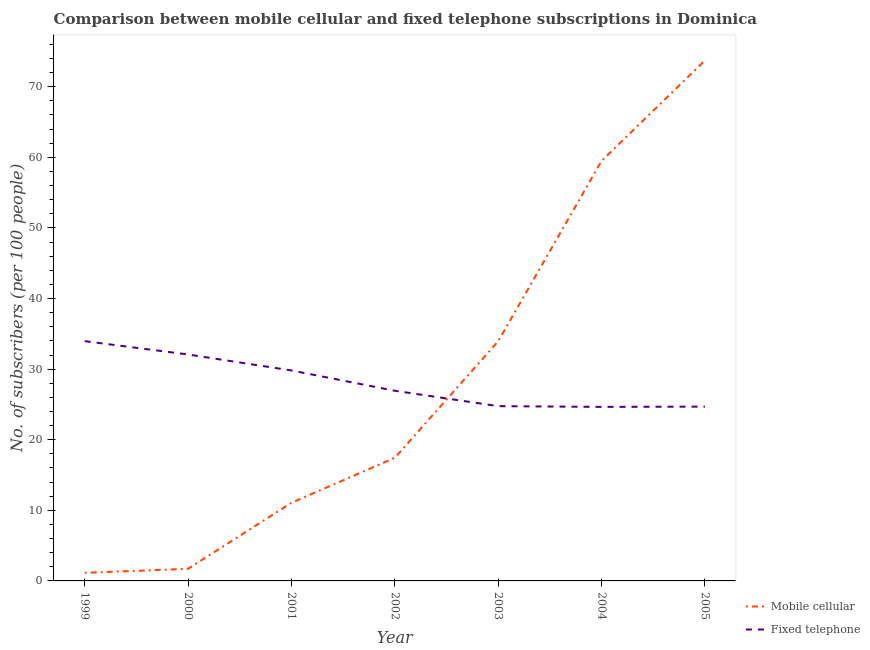Does the line corresponding to number of mobile cellular subscribers intersect with the line corresponding to number of fixed telephone subscribers?
Provide a short and direct response. Yes. Is the number of lines equal to the number of legend labels?
Your response must be concise. Yes. What is the number of mobile cellular subscribers in 2004?
Your answer should be compact. 59.49. Across all years, what is the maximum number of mobile cellular subscribers?
Offer a very short reply. 73.71. Across all years, what is the minimum number of fixed telephone subscribers?
Offer a very short reply. 24.65. In which year was the number of mobile cellular subscribers minimum?
Provide a short and direct response. 1999. What is the total number of mobile cellular subscribers in the graph?
Offer a terse response. 198.53. What is the difference between the number of fixed telephone subscribers in 2002 and that in 2005?
Your answer should be very brief. 2.25. What is the difference between the number of mobile cellular subscribers in 2003 and the number of fixed telephone subscribers in 1999?
Your response must be concise. -0.01. What is the average number of mobile cellular subscribers per year?
Offer a terse response. 28.36. In the year 2002, what is the difference between the number of mobile cellular subscribers and number of fixed telephone subscribers?
Keep it short and to the point. -9.5. What is the ratio of the number of mobile cellular subscribers in 2003 to that in 2004?
Provide a short and direct response. 0.57. Is the number of mobile cellular subscribers in 2001 less than that in 2003?
Offer a terse response. Yes. Is the difference between the number of mobile cellular subscribers in 2000 and 2004 greater than the difference between the number of fixed telephone subscribers in 2000 and 2004?
Offer a very short reply. No. What is the difference between the highest and the second highest number of fixed telephone subscribers?
Give a very brief answer. 1.89. What is the difference between the highest and the lowest number of fixed telephone subscribers?
Your answer should be compact. 9.31. In how many years, is the number of fixed telephone subscribers greater than the average number of fixed telephone subscribers taken over all years?
Your answer should be very brief. 3. Is the number of fixed telephone subscribers strictly less than the number of mobile cellular subscribers over the years?
Ensure brevity in your answer.  No. How many years are there in the graph?
Offer a terse response. 7. What is the difference between two consecutive major ticks on the Y-axis?
Provide a succinct answer. 10. Where does the legend appear in the graph?
Your answer should be compact. Bottom right. How many legend labels are there?
Your answer should be compact. 2. How are the legend labels stacked?
Your response must be concise. Vertical. What is the title of the graph?
Give a very brief answer. Comparison between mobile cellular and fixed telephone subscriptions in Dominica. What is the label or title of the X-axis?
Ensure brevity in your answer.  Year. What is the label or title of the Y-axis?
Keep it short and to the point. No. of subscribers (per 100 people). What is the No. of subscribers (per 100 people) of Mobile cellular in 1999?
Provide a short and direct response. 1.14. What is the No. of subscribers (per 100 people) of Fixed telephone in 1999?
Keep it short and to the point. 33.96. What is the No. of subscribers (per 100 people) in Mobile cellular in 2000?
Give a very brief answer. 1.72. What is the No. of subscribers (per 100 people) in Fixed telephone in 2000?
Your response must be concise. 32.07. What is the No. of subscribers (per 100 people) of Mobile cellular in 2001?
Provide a succinct answer. 11.07. What is the No. of subscribers (per 100 people) of Fixed telephone in 2001?
Offer a very short reply. 29.81. What is the No. of subscribers (per 100 people) in Mobile cellular in 2002?
Your answer should be compact. 17.44. What is the No. of subscribers (per 100 people) of Fixed telephone in 2002?
Your response must be concise. 26.93. What is the No. of subscribers (per 100 people) of Mobile cellular in 2003?
Keep it short and to the point. 33.95. What is the No. of subscribers (per 100 people) in Fixed telephone in 2003?
Offer a very short reply. 24.76. What is the No. of subscribers (per 100 people) of Mobile cellular in 2004?
Provide a short and direct response. 59.49. What is the No. of subscribers (per 100 people) in Fixed telephone in 2004?
Provide a short and direct response. 24.65. What is the No. of subscribers (per 100 people) of Mobile cellular in 2005?
Offer a terse response. 73.71. What is the No. of subscribers (per 100 people) of Fixed telephone in 2005?
Give a very brief answer. 24.69. Across all years, what is the maximum No. of subscribers (per 100 people) of Mobile cellular?
Offer a very short reply. 73.71. Across all years, what is the maximum No. of subscribers (per 100 people) of Fixed telephone?
Provide a succinct answer. 33.96. Across all years, what is the minimum No. of subscribers (per 100 people) in Mobile cellular?
Your answer should be very brief. 1.14. Across all years, what is the minimum No. of subscribers (per 100 people) of Fixed telephone?
Ensure brevity in your answer.  24.65. What is the total No. of subscribers (per 100 people) of Mobile cellular in the graph?
Give a very brief answer. 198.53. What is the total No. of subscribers (per 100 people) of Fixed telephone in the graph?
Offer a terse response. 196.87. What is the difference between the No. of subscribers (per 100 people) of Mobile cellular in 1999 and that in 2000?
Provide a short and direct response. -0.58. What is the difference between the No. of subscribers (per 100 people) of Fixed telephone in 1999 and that in 2000?
Ensure brevity in your answer.  1.89. What is the difference between the No. of subscribers (per 100 people) of Mobile cellular in 1999 and that in 2001?
Provide a succinct answer. -9.92. What is the difference between the No. of subscribers (per 100 people) of Fixed telephone in 1999 and that in 2001?
Your answer should be very brief. 4.15. What is the difference between the No. of subscribers (per 100 people) in Mobile cellular in 1999 and that in 2002?
Make the answer very short. -16.29. What is the difference between the No. of subscribers (per 100 people) of Fixed telephone in 1999 and that in 2002?
Give a very brief answer. 7.03. What is the difference between the No. of subscribers (per 100 people) of Mobile cellular in 1999 and that in 2003?
Ensure brevity in your answer.  -32.81. What is the difference between the No. of subscribers (per 100 people) of Fixed telephone in 1999 and that in 2003?
Make the answer very short. 9.21. What is the difference between the No. of subscribers (per 100 people) in Mobile cellular in 1999 and that in 2004?
Keep it short and to the point. -58.35. What is the difference between the No. of subscribers (per 100 people) in Fixed telephone in 1999 and that in 2004?
Ensure brevity in your answer.  9.31. What is the difference between the No. of subscribers (per 100 people) of Mobile cellular in 1999 and that in 2005?
Provide a succinct answer. -72.57. What is the difference between the No. of subscribers (per 100 people) in Fixed telephone in 1999 and that in 2005?
Ensure brevity in your answer.  9.27. What is the difference between the No. of subscribers (per 100 people) of Mobile cellular in 2000 and that in 2001?
Make the answer very short. -9.35. What is the difference between the No. of subscribers (per 100 people) of Fixed telephone in 2000 and that in 2001?
Offer a terse response. 2.26. What is the difference between the No. of subscribers (per 100 people) in Mobile cellular in 2000 and that in 2002?
Your response must be concise. -15.72. What is the difference between the No. of subscribers (per 100 people) in Fixed telephone in 2000 and that in 2002?
Provide a short and direct response. 5.14. What is the difference between the No. of subscribers (per 100 people) in Mobile cellular in 2000 and that in 2003?
Offer a very short reply. -32.23. What is the difference between the No. of subscribers (per 100 people) of Fixed telephone in 2000 and that in 2003?
Offer a very short reply. 7.31. What is the difference between the No. of subscribers (per 100 people) in Mobile cellular in 2000 and that in 2004?
Make the answer very short. -57.77. What is the difference between the No. of subscribers (per 100 people) of Fixed telephone in 2000 and that in 2004?
Offer a terse response. 7.42. What is the difference between the No. of subscribers (per 100 people) in Mobile cellular in 2000 and that in 2005?
Ensure brevity in your answer.  -71.99. What is the difference between the No. of subscribers (per 100 people) of Fixed telephone in 2000 and that in 2005?
Your answer should be compact. 7.38. What is the difference between the No. of subscribers (per 100 people) of Mobile cellular in 2001 and that in 2002?
Your response must be concise. -6.37. What is the difference between the No. of subscribers (per 100 people) in Fixed telephone in 2001 and that in 2002?
Ensure brevity in your answer.  2.87. What is the difference between the No. of subscribers (per 100 people) of Mobile cellular in 2001 and that in 2003?
Offer a terse response. -22.88. What is the difference between the No. of subscribers (per 100 people) in Fixed telephone in 2001 and that in 2003?
Your answer should be compact. 5.05. What is the difference between the No. of subscribers (per 100 people) of Mobile cellular in 2001 and that in 2004?
Offer a very short reply. -48.42. What is the difference between the No. of subscribers (per 100 people) in Fixed telephone in 2001 and that in 2004?
Provide a succinct answer. 5.16. What is the difference between the No. of subscribers (per 100 people) of Mobile cellular in 2001 and that in 2005?
Offer a terse response. -62.65. What is the difference between the No. of subscribers (per 100 people) in Fixed telephone in 2001 and that in 2005?
Your answer should be compact. 5.12. What is the difference between the No. of subscribers (per 100 people) of Mobile cellular in 2002 and that in 2003?
Keep it short and to the point. -16.51. What is the difference between the No. of subscribers (per 100 people) in Fixed telephone in 2002 and that in 2003?
Your answer should be very brief. 2.18. What is the difference between the No. of subscribers (per 100 people) in Mobile cellular in 2002 and that in 2004?
Provide a short and direct response. -42.05. What is the difference between the No. of subscribers (per 100 people) of Fixed telephone in 2002 and that in 2004?
Provide a short and direct response. 2.29. What is the difference between the No. of subscribers (per 100 people) in Mobile cellular in 2002 and that in 2005?
Provide a short and direct response. -56.28. What is the difference between the No. of subscribers (per 100 people) in Fixed telephone in 2002 and that in 2005?
Your answer should be very brief. 2.25. What is the difference between the No. of subscribers (per 100 people) in Mobile cellular in 2003 and that in 2004?
Provide a short and direct response. -25.54. What is the difference between the No. of subscribers (per 100 people) of Fixed telephone in 2003 and that in 2004?
Provide a short and direct response. 0.11. What is the difference between the No. of subscribers (per 100 people) of Mobile cellular in 2003 and that in 2005?
Provide a short and direct response. -39.76. What is the difference between the No. of subscribers (per 100 people) of Fixed telephone in 2003 and that in 2005?
Make the answer very short. 0.07. What is the difference between the No. of subscribers (per 100 people) in Mobile cellular in 2004 and that in 2005?
Offer a terse response. -14.22. What is the difference between the No. of subscribers (per 100 people) in Fixed telephone in 2004 and that in 2005?
Offer a terse response. -0.04. What is the difference between the No. of subscribers (per 100 people) in Mobile cellular in 1999 and the No. of subscribers (per 100 people) in Fixed telephone in 2000?
Provide a short and direct response. -30.93. What is the difference between the No. of subscribers (per 100 people) of Mobile cellular in 1999 and the No. of subscribers (per 100 people) of Fixed telephone in 2001?
Your answer should be very brief. -28.66. What is the difference between the No. of subscribers (per 100 people) in Mobile cellular in 1999 and the No. of subscribers (per 100 people) in Fixed telephone in 2002?
Keep it short and to the point. -25.79. What is the difference between the No. of subscribers (per 100 people) of Mobile cellular in 1999 and the No. of subscribers (per 100 people) of Fixed telephone in 2003?
Make the answer very short. -23.61. What is the difference between the No. of subscribers (per 100 people) of Mobile cellular in 1999 and the No. of subscribers (per 100 people) of Fixed telephone in 2004?
Make the answer very short. -23.5. What is the difference between the No. of subscribers (per 100 people) of Mobile cellular in 1999 and the No. of subscribers (per 100 people) of Fixed telephone in 2005?
Keep it short and to the point. -23.54. What is the difference between the No. of subscribers (per 100 people) in Mobile cellular in 2000 and the No. of subscribers (per 100 people) in Fixed telephone in 2001?
Provide a succinct answer. -28.09. What is the difference between the No. of subscribers (per 100 people) of Mobile cellular in 2000 and the No. of subscribers (per 100 people) of Fixed telephone in 2002?
Keep it short and to the point. -25.21. What is the difference between the No. of subscribers (per 100 people) in Mobile cellular in 2000 and the No. of subscribers (per 100 people) in Fixed telephone in 2003?
Give a very brief answer. -23.03. What is the difference between the No. of subscribers (per 100 people) of Mobile cellular in 2000 and the No. of subscribers (per 100 people) of Fixed telephone in 2004?
Offer a very short reply. -22.93. What is the difference between the No. of subscribers (per 100 people) in Mobile cellular in 2000 and the No. of subscribers (per 100 people) in Fixed telephone in 2005?
Offer a very short reply. -22.97. What is the difference between the No. of subscribers (per 100 people) in Mobile cellular in 2001 and the No. of subscribers (per 100 people) in Fixed telephone in 2002?
Keep it short and to the point. -15.87. What is the difference between the No. of subscribers (per 100 people) in Mobile cellular in 2001 and the No. of subscribers (per 100 people) in Fixed telephone in 2003?
Provide a succinct answer. -13.69. What is the difference between the No. of subscribers (per 100 people) of Mobile cellular in 2001 and the No. of subscribers (per 100 people) of Fixed telephone in 2004?
Your response must be concise. -13.58. What is the difference between the No. of subscribers (per 100 people) in Mobile cellular in 2001 and the No. of subscribers (per 100 people) in Fixed telephone in 2005?
Ensure brevity in your answer.  -13.62. What is the difference between the No. of subscribers (per 100 people) of Mobile cellular in 2002 and the No. of subscribers (per 100 people) of Fixed telephone in 2003?
Offer a very short reply. -7.32. What is the difference between the No. of subscribers (per 100 people) of Mobile cellular in 2002 and the No. of subscribers (per 100 people) of Fixed telephone in 2004?
Offer a terse response. -7.21. What is the difference between the No. of subscribers (per 100 people) in Mobile cellular in 2002 and the No. of subscribers (per 100 people) in Fixed telephone in 2005?
Your answer should be compact. -7.25. What is the difference between the No. of subscribers (per 100 people) in Mobile cellular in 2003 and the No. of subscribers (per 100 people) in Fixed telephone in 2004?
Ensure brevity in your answer.  9.3. What is the difference between the No. of subscribers (per 100 people) in Mobile cellular in 2003 and the No. of subscribers (per 100 people) in Fixed telephone in 2005?
Your answer should be very brief. 9.26. What is the difference between the No. of subscribers (per 100 people) in Mobile cellular in 2004 and the No. of subscribers (per 100 people) in Fixed telephone in 2005?
Provide a succinct answer. 34.8. What is the average No. of subscribers (per 100 people) in Mobile cellular per year?
Give a very brief answer. 28.36. What is the average No. of subscribers (per 100 people) in Fixed telephone per year?
Your answer should be very brief. 28.12. In the year 1999, what is the difference between the No. of subscribers (per 100 people) of Mobile cellular and No. of subscribers (per 100 people) of Fixed telephone?
Make the answer very short. -32.82. In the year 2000, what is the difference between the No. of subscribers (per 100 people) of Mobile cellular and No. of subscribers (per 100 people) of Fixed telephone?
Give a very brief answer. -30.35. In the year 2001, what is the difference between the No. of subscribers (per 100 people) in Mobile cellular and No. of subscribers (per 100 people) in Fixed telephone?
Make the answer very short. -18.74. In the year 2002, what is the difference between the No. of subscribers (per 100 people) of Mobile cellular and No. of subscribers (per 100 people) of Fixed telephone?
Provide a succinct answer. -9.5. In the year 2003, what is the difference between the No. of subscribers (per 100 people) of Mobile cellular and No. of subscribers (per 100 people) of Fixed telephone?
Ensure brevity in your answer.  9.2. In the year 2004, what is the difference between the No. of subscribers (per 100 people) of Mobile cellular and No. of subscribers (per 100 people) of Fixed telephone?
Give a very brief answer. 34.84. In the year 2005, what is the difference between the No. of subscribers (per 100 people) in Mobile cellular and No. of subscribers (per 100 people) in Fixed telephone?
Keep it short and to the point. 49.03. What is the ratio of the No. of subscribers (per 100 people) in Mobile cellular in 1999 to that in 2000?
Your answer should be very brief. 0.66. What is the ratio of the No. of subscribers (per 100 people) of Fixed telephone in 1999 to that in 2000?
Offer a very short reply. 1.06. What is the ratio of the No. of subscribers (per 100 people) in Mobile cellular in 1999 to that in 2001?
Provide a short and direct response. 0.1. What is the ratio of the No. of subscribers (per 100 people) in Fixed telephone in 1999 to that in 2001?
Provide a short and direct response. 1.14. What is the ratio of the No. of subscribers (per 100 people) in Mobile cellular in 1999 to that in 2002?
Your answer should be compact. 0.07. What is the ratio of the No. of subscribers (per 100 people) of Fixed telephone in 1999 to that in 2002?
Give a very brief answer. 1.26. What is the ratio of the No. of subscribers (per 100 people) of Mobile cellular in 1999 to that in 2003?
Ensure brevity in your answer.  0.03. What is the ratio of the No. of subscribers (per 100 people) of Fixed telephone in 1999 to that in 2003?
Make the answer very short. 1.37. What is the ratio of the No. of subscribers (per 100 people) of Mobile cellular in 1999 to that in 2004?
Provide a succinct answer. 0.02. What is the ratio of the No. of subscribers (per 100 people) in Fixed telephone in 1999 to that in 2004?
Ensure brevity in your answer.  1.38. What is the ratio of the No. of subscribers (per 100 people) of Mobile cellular in 1999 to that in 2005?
Keep it short and to the point. 0.02. What is the ratio of the No. of subscribers (per 100 people) in Fixed telephone in 1999 to that in 2005?
Provide a succinct answer. 1.38. What is the ratio of the No. of subscribers (per 100 people) of Mobile cellular in 2000 to that in 2001?
Keep it short and to the point. 0.16. What is the ratio of the No. of subscribers (per 100 people) of Fixed telephone in 2000 to that in 2001?
Provide a succinct answer. 1.08. What is the ratio of the No. of subscribers (per 100 people) of Mobile cellular in 2000 to that in 2002?
Offer a terse response. 0.1. What is the ratio of the No. of subscribers (per 100 people) in Fixed telephone in 2000 to that in 2002?
Your answer should be very brief. 1.19. What is the ratio of the No. of subscribers (per 100 people) in Mobile cellular in 2000 to that in 2003?
Your answer should be very brief. 0.05. What is the ratio of the No. of subscribers (per 100 people) of Fixed telephone in 2000 to that in 2003?
Provide a succinct answer. 1.3. What is the ratio of the No. of subscribers (per 100 people) of Mobile cellular in 2000 to that in 2004?
Ensure brevity in your answer.  0.03. What is the ratio of the No. of subscribers (per 100 people) of Fixed telephone in 2000 to that in 2004?
Offer a very short reply. 1.3. What is the ratio of the No. of subscribers (per 100 people) in Mobile cellular in 2000 to that in 2005?
Your answer should be very brief. 0.02. What is the ratio of the No. of subscribers (per 100 people) of Fixed telephone in 2000 to that in 2005?
Offer a terse response. 1.3. What is the ratio of the No. of subscribers (per 100 people) of Mobile cellular in 2001 to that in 2002?
Make the answer very short. 0.63. What is the ratio of the No. of subscribers (per 100 people) in Fixed telephone in 2001 to that in 2002?
Provide a short and direct response. 1.11. What is the ratio of the No. of subscribers (per 100 people) in Mobile cellular in 2001 to that in 2003?
Give a very brief answer. 0.33. What is the ratio of the No. of subscribers (per 100 people) of Fixed telephone in 2001 to that in 2003?
Provide a short and direct response. 1.2. What is the ratio of the No. of subscribers (per 100 people) in Mobile cellular in 2001 to that in 2004?
Your answer should be very brief. 0.19. What is the ratio of the No. of subscribers (per 100 people) of Fixed telephone in 2001 to that in 2004?
Provide a succinct answer. 1.21. What is the ratio of the No. of subscribers (per 100 people) of Mobile cellular in 2001 to that in 2005?
Your answer should be compact. 0.15. What is the ratio of the No. of subscribers (per 100 people) of Fixed telephone in 2001 to that in 2005?
Your response must be concise. 1.21. What is the ratio of the No. of subscribers (per 100 people) of Mobile cellular in 2002 to that in 2003?
Your response must be concise. 0.51. What is the ratio of the No. of subscribers (per 100 people) of Fixed telephone in 2002 to that in 2003?
Offer a very short reply. 1.09. What is the ratio of the No. of subscribers (per 100 people) in Mobile cellular in 2002 to that in 2004?
Provide a short and direct response. 0.29. What is the ratio of the No. of subscribers (per 100 people) in Fixed telephone in 2002 to that in 2004?
Keep it short and to the point. 1.09. What is the ratio of the No. of subscribers (per 100 people) of Mobile cellular in 2002 to that in 2005?
Give a very brief answer. 0.24. What is the ratio of the No. of subscribers (per 100 people) of Fixed telephone in 2002 to that in 2005?
Your response must be concise. 1.09. What is the ratio of the No. of subscribers (per 100 people) of Mobile cellular in 2003 to that in 2004?
Your answer should be compact. 0.57. What is the ratio of the No. of subscribers (per 100 people) in Fixed telephone in 2003 to that in 2004?
Your answer should be compact. 1. What is the ratio of the No. of subscribers (per 100 people) in Mobile cellular in 2003 to that in 2005?
Offer a very short reply. 0.46. What is the ratio of the No. of subscribers (per 100 people) in Fixed telephone in 2003 to that in 2005?
Make the answer very short. 1. What is the ratio of the No. of subscribers (per 100 people) in Mobile cellular in 2004 to that in 2005?
Offer a very short reply. 0.81. What is the difference between the highest and the second highest No. of subscribers (per 100 people) of Mobile cellular?
Keep it short and to the point. 14.22. What is the difference between the highest and the second highest No. of subscribers (per 100 people) of Fixed telephone?
Your response must be concise. 1.89. What is the difference between the highest and the lowest No. of subscribers (per 100 people) of Mobile cellular?
Your answer should be compact. 72.57. What is the difference between the highest and the lowest No. of subscribers (per 100 people) of Fixed telephone?
Your answer should be compact. 9.31. 